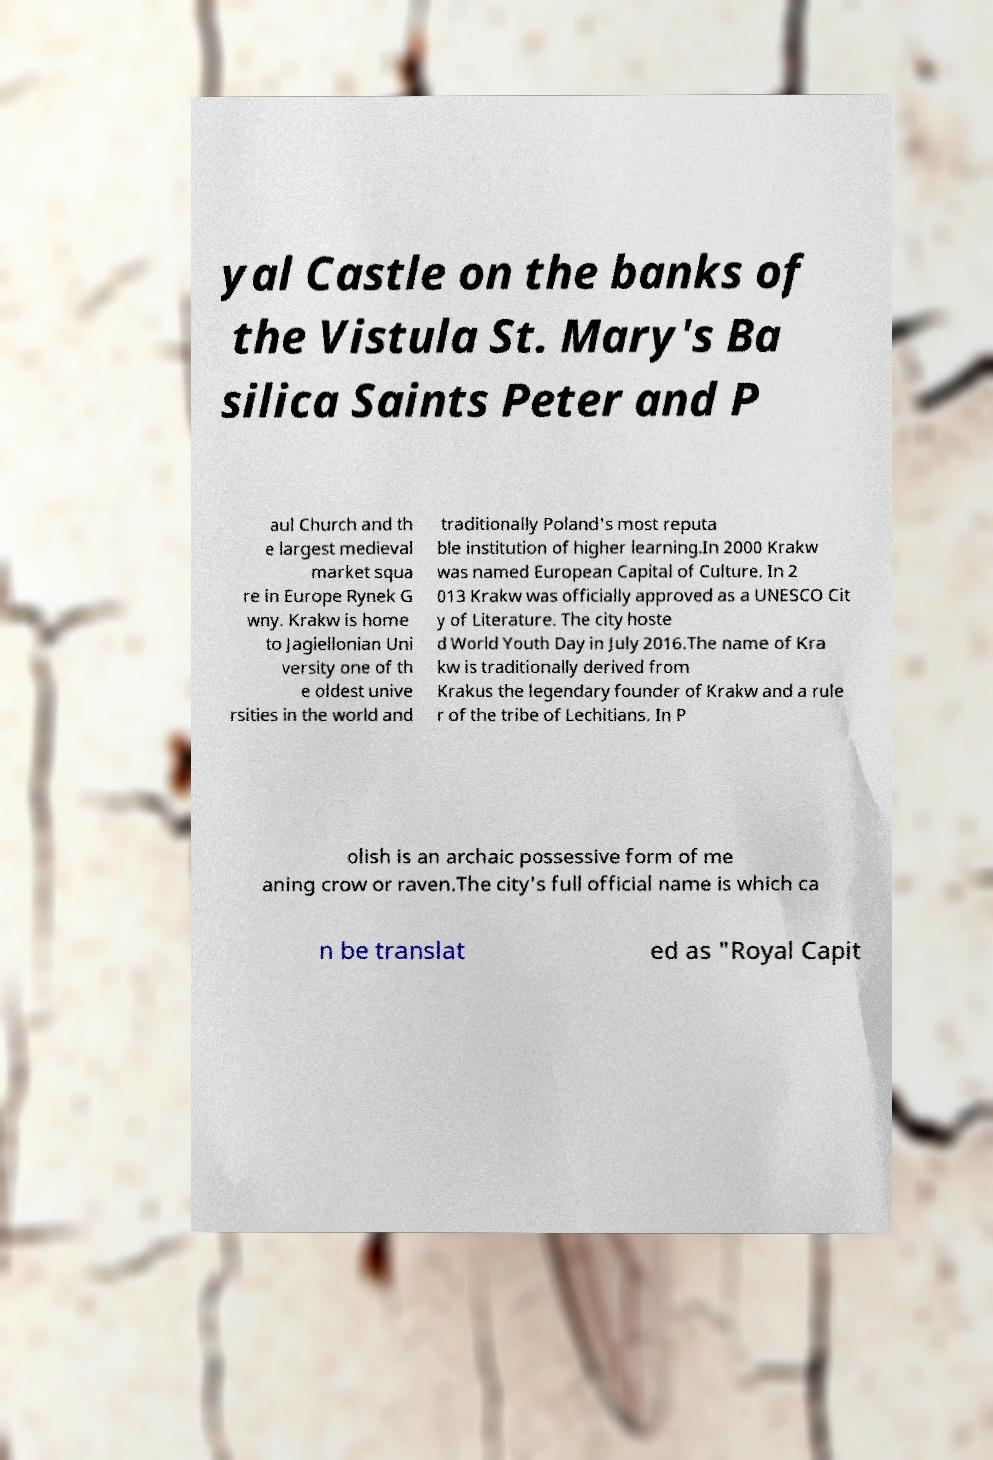Please identify and transcribe the text found in this image. yal Castle on the banks of the Vistula St. Mary's Ba silica Saints Peter and P aul Church and th e largest medieval market squa re in Europe Rynek G wny. Krakw is home to Jagiellonian Uni versity one of th e oldest unive rsities in the world and traditionally Poland's most reputa ble institution of higher learning.In 2000 Krakw was named European Capital of Culture. In 2 013 Krakw was officially approved as a UNESCO Cit y of Literature. The city hoste d World Youth Day in July 2016.The name of Kra kw is traditionally derived from Krakus the legendary founder of Krakw and a rule r of the tribe of Lechitians. In P olish is an archaic possessive form of me aning crow or raven.The city's full official name is which ca n be translat ed as "Royal Capit 